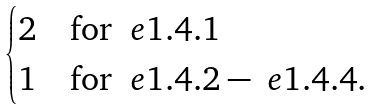Convert formula to latex. <formula><loc_0><loc_0><loc_500><loc_500>\begin{cases} 2 & \text {for } \ e { 1 . 4 . 1 } \\ 1 & \text {for } \ e { 1 . 4 . 2 } - \ e { 1 . 4 . 4 } . \end{cases}</formula> 